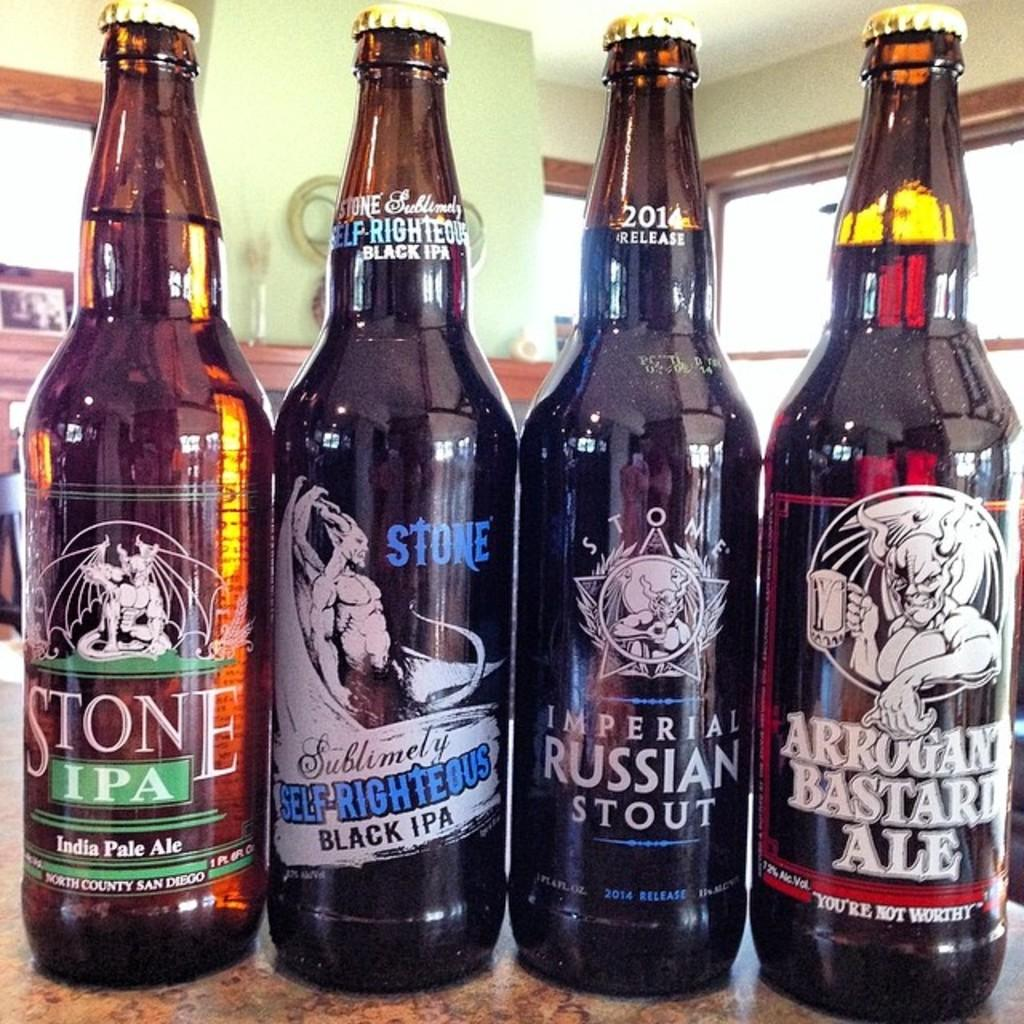Provide a one-sentence caption for the provided image. Four bottles of beer are lined up including a bottle of Imperial Russian stout. 